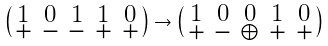<formula> <loc_0><loc_0><loc_500><loc_500>\left ( \begin{smallmatrix} 1 & 0 & 1 & 1 & 0 \\ + & - & - & + & + \\ \end{smallmatrix} \right ) \to \left ( \begin{smallmatrix} 1 & 0 & 0 & 1 & 0 \\ + & - & \oplus & + & + \\ \end{smallmatrix} \right )</formula> 